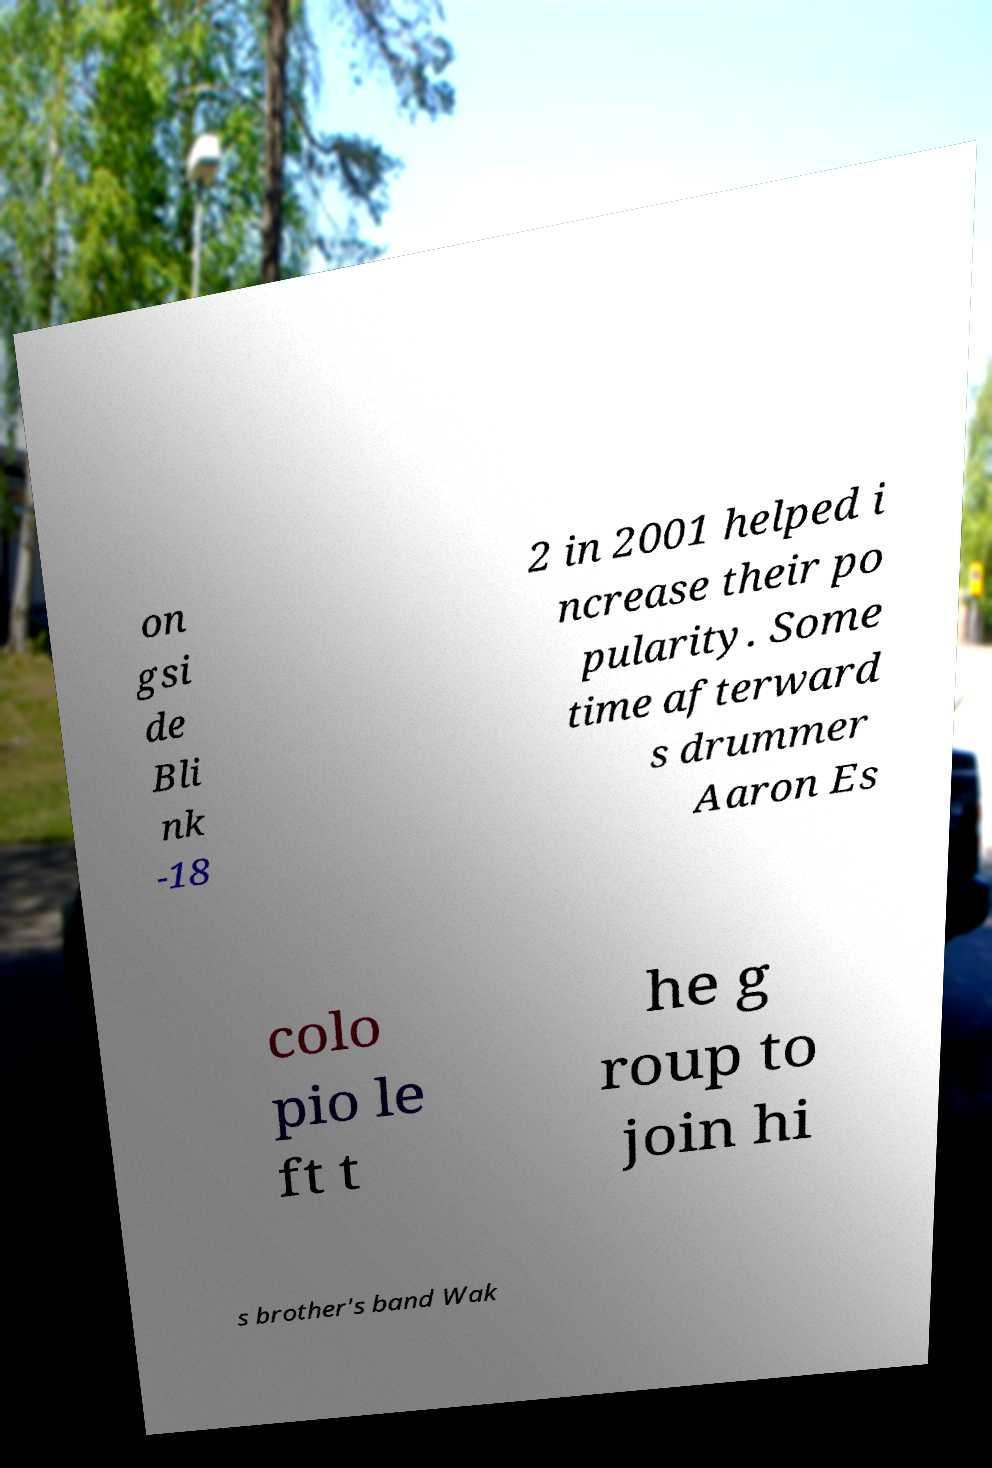Could you extract and type out the text from this image? on gsi de Bli nk -18 2 in 2001 helped i ncrease their po pularity. Some time afterward s drummer Aaron Es colo pio le ft t he g roup to join hi s brother's band Wak 